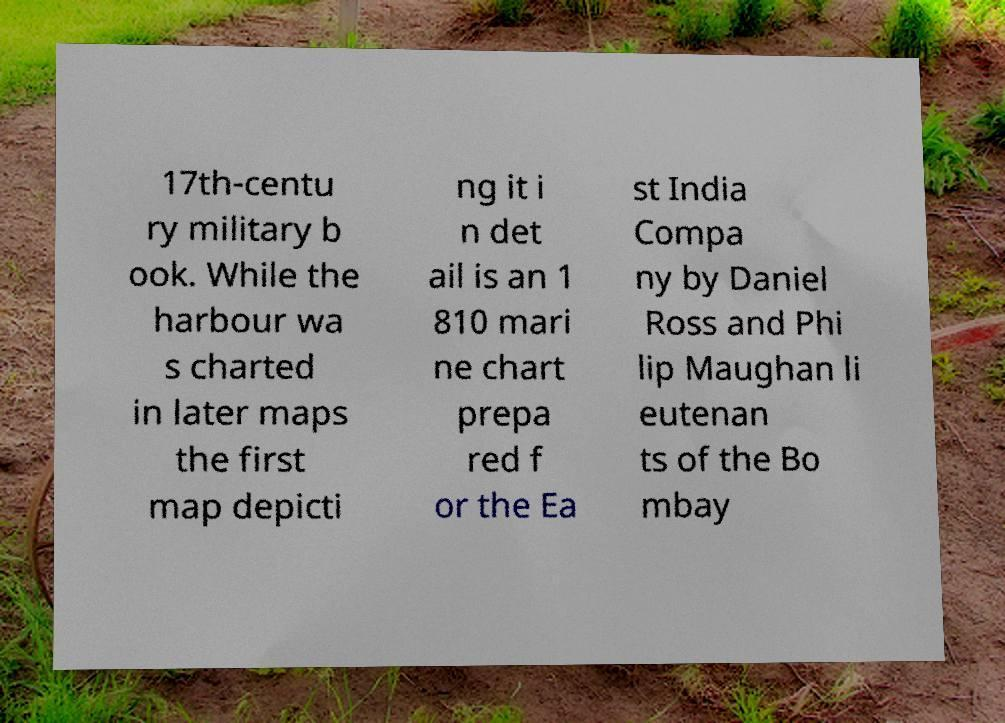Can you read and provide the text displayed in the image?This photo seems to have some interesting text. Can you extract and type it out for me? 17th-centu ry military b ook. While the harbour wa s charted in later maps the first map depicti ng it i n det ail is an 1 810 mari ne chart prepa red f or the Ea st India Compa ny by Daniel Ross and Phi lip Maughan li eutenan ts of the Bo mbay 